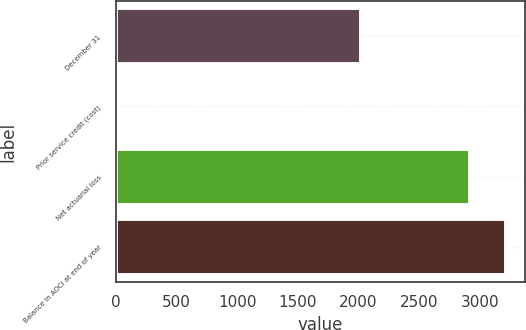Convert chart. <chart><loc_0><loc_0><loc_500><loc_500><bar_chart><fcel>December 31<fcel>Prior service credit (cost)<fcel>Net actuarial loss<fcel>Balance in AOCI at end of year<nl><fcel>2016<fcel>14<fcel>2918<fcel>3209.8<nl></chart> 